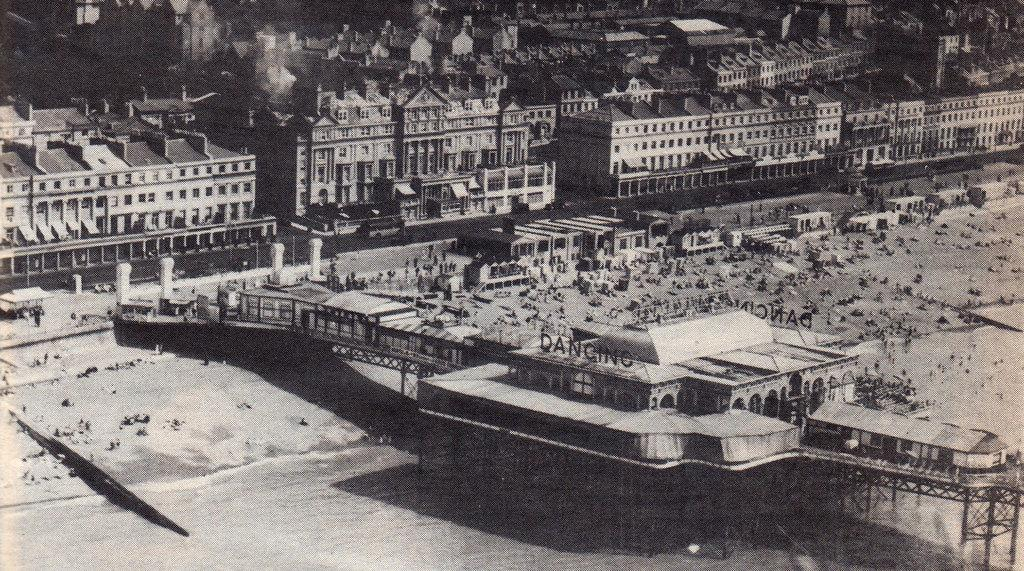What type of structures can be seen in the image? There are many buildings in the image. Are there any people present in the image? Yes, there are people in the image. What connects the two sides of the water in the image? There is a bridge in the image. What can be found at the bottom of the image? There is water and sand at the bottom of the image. What type of pocket can be seen in the image? There is no pocket present in the image. What is the mouth of the river in the image? There is no river mentioned in the image, only water at the bottom. 